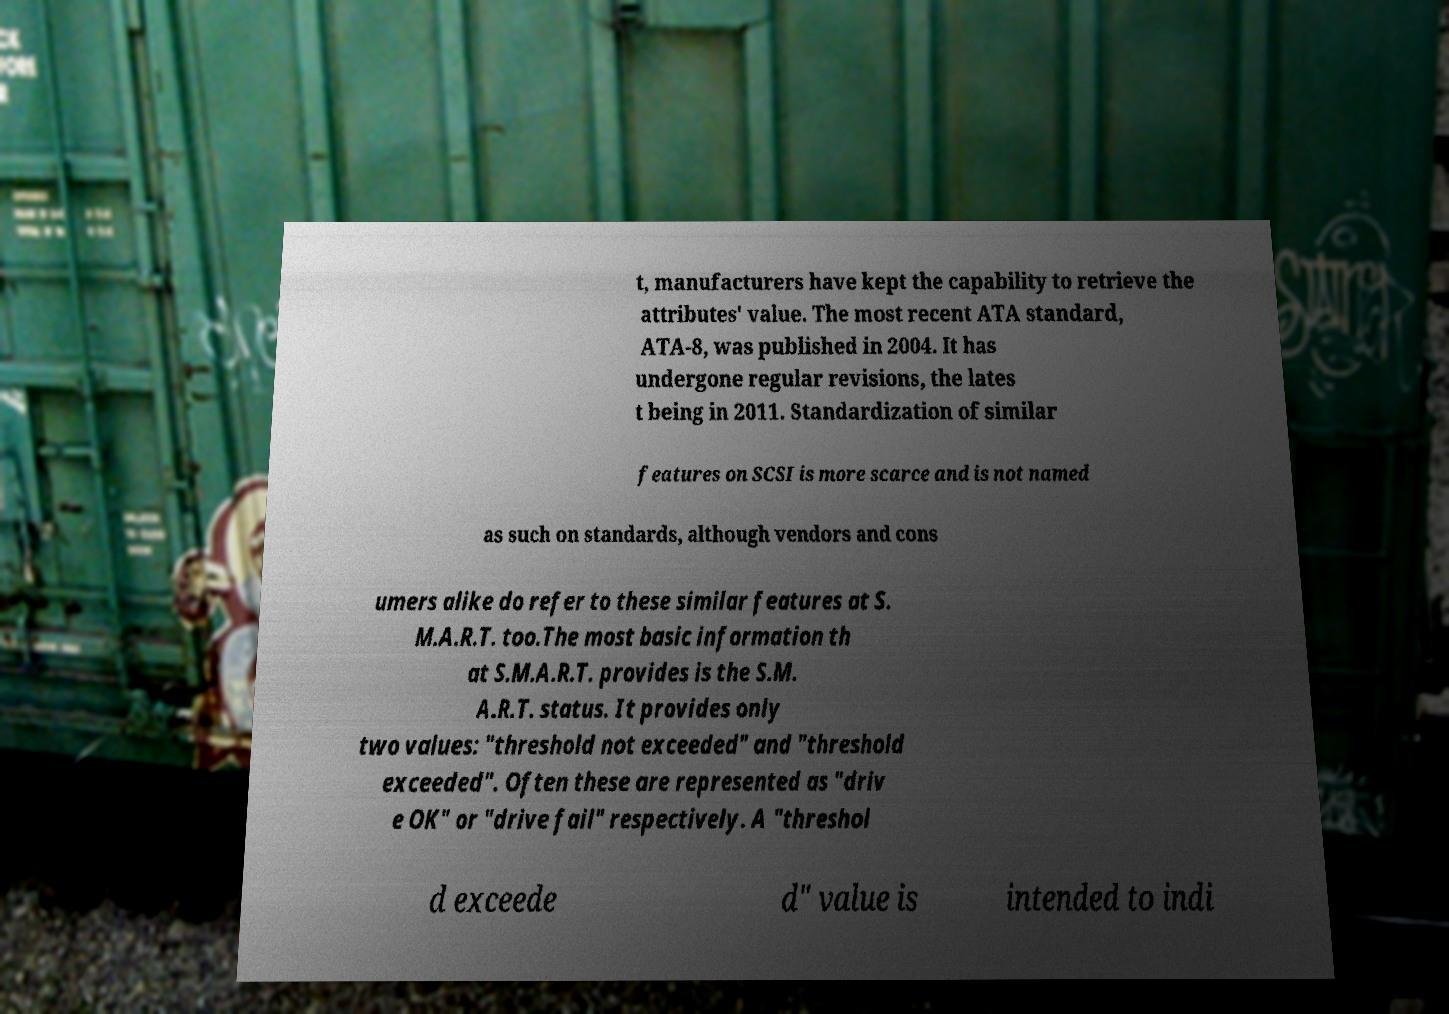I need the written content from this picture converted into text. Can you do that? t, manufacturers have kept the capability to retrieve the attributes' value. The most recent ATA standard, ATA-8, was published in 2004. It has undergone regular revisions, the lates t being in 2011. Standardization of similar features on SCSI is more scarce and is not named as such on standards, although vendors and cons umers alike do refer to these similar features at S. M.A.R.T. too.The most basic information th at S.M.A.R.T. provides is the S.M. A.R.T. status. It provides only two values: "threshold not exceeded" and "threshold exceeded". Often these are represented as "driv e OK" or "drive fail" respectively. A "threshol d exceede d" value is intended to indi 